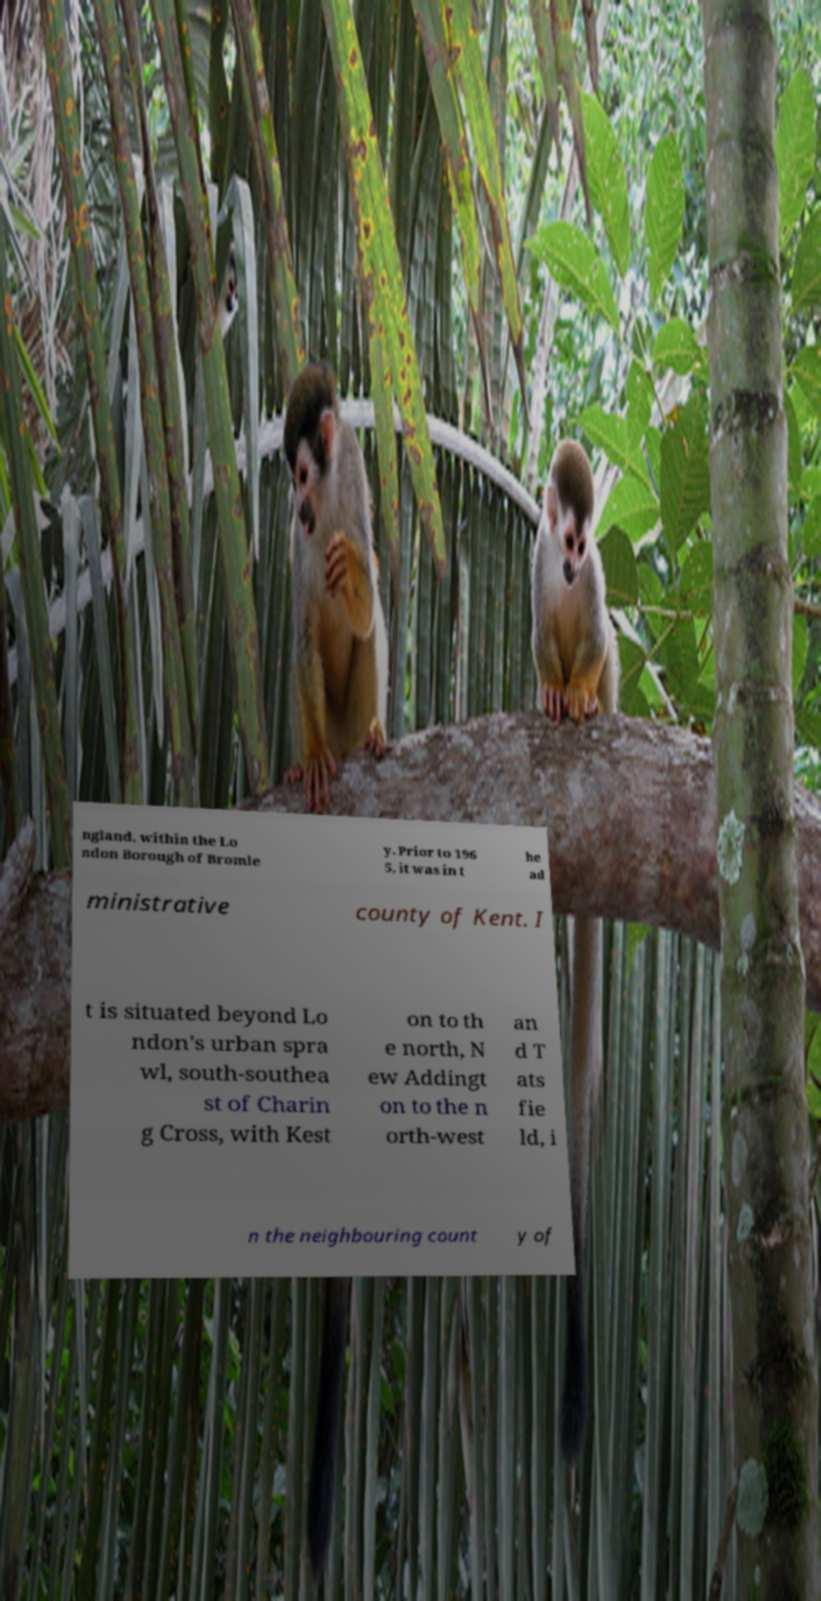Please identify and transcribe the text found in this image. ngland, within the Lo ndon Borough of Bromle y. Prior to 196 5, it was in t he ad ministrative county of Kent. I t is situated beyond Lo ndon's urban spra wl, south-southea st of Charin g Cross, with Kest on to th e north, N ew Addingt on to the n orth-west an d T ats fie ld, i n the neighbouring count y of 